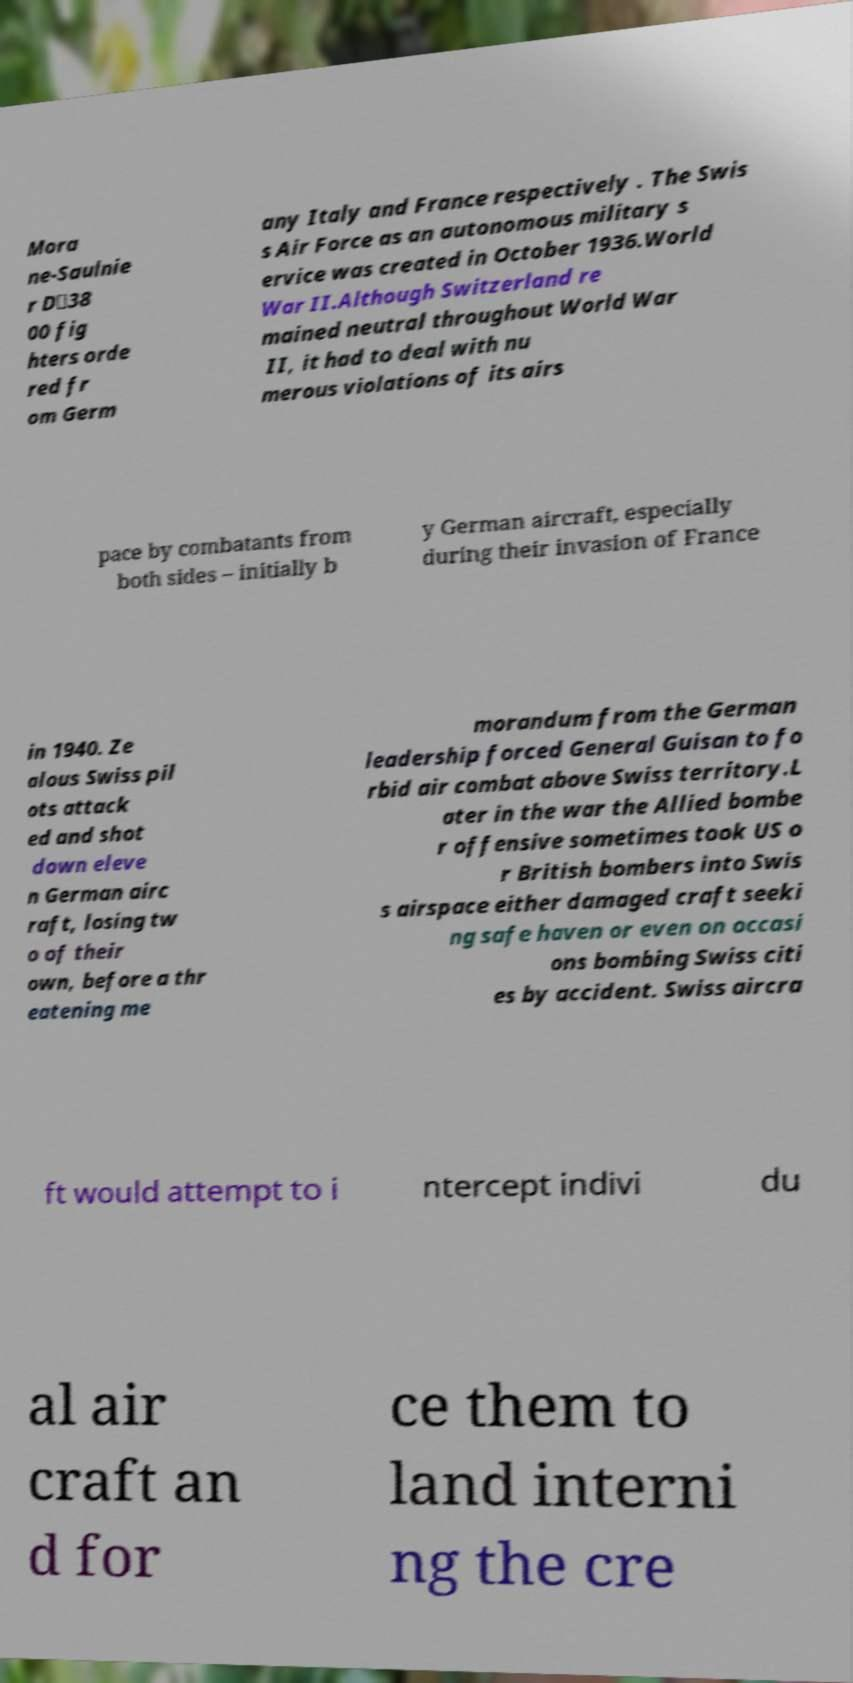Please identify and transcribe the text found in this image. Mora ne-Saulnie r D‐38 00 fig hters orde red fr om Germ any Italy and France respectively . The Swis s Air Force as an autonomous military s ervice was created in October 1936.World War II.Although Switzerland re mained neutral throughout World War II, it had to deal with nu merous violations of its airs pace by combatants from both sides – initially b y German aircraft, especially during their invasion of France in 1940. Ze alous Swiss pil ots attack ed and shot down eleve n German airc raft, losing tw o of their own, before a thr eatening me morandum from the German leadership forced General Guisan to fo rbid air combat above Swiss territory.L ater in the war the Allied bombe r offensive sometimes took US o r British bombers into Swis s airspace either damaged craft seeki ng safe haven or even on occasi ons bombing Swiss citi es by accident. Swiss aircra ft would attempt to i ntercept indivi du al air craft an d for ce them to land interni ng the cre 